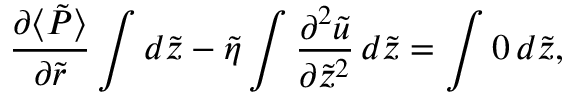Convert formula to latex. <formula><loc_0><loc_0><loc_500><loc_500>\frac { \partial \langle \tilde { P } \rangle } { \partial \tilde { r } } \int d \tilde { z } - \tilde { \eta } \int \frac { \partial ^ { 2 } \tilde { u } } { \partial \tilde { z } ^ { 2 } } \, d \tilde { z } = \int 0 \, d \tilde { z } ,</formula> 